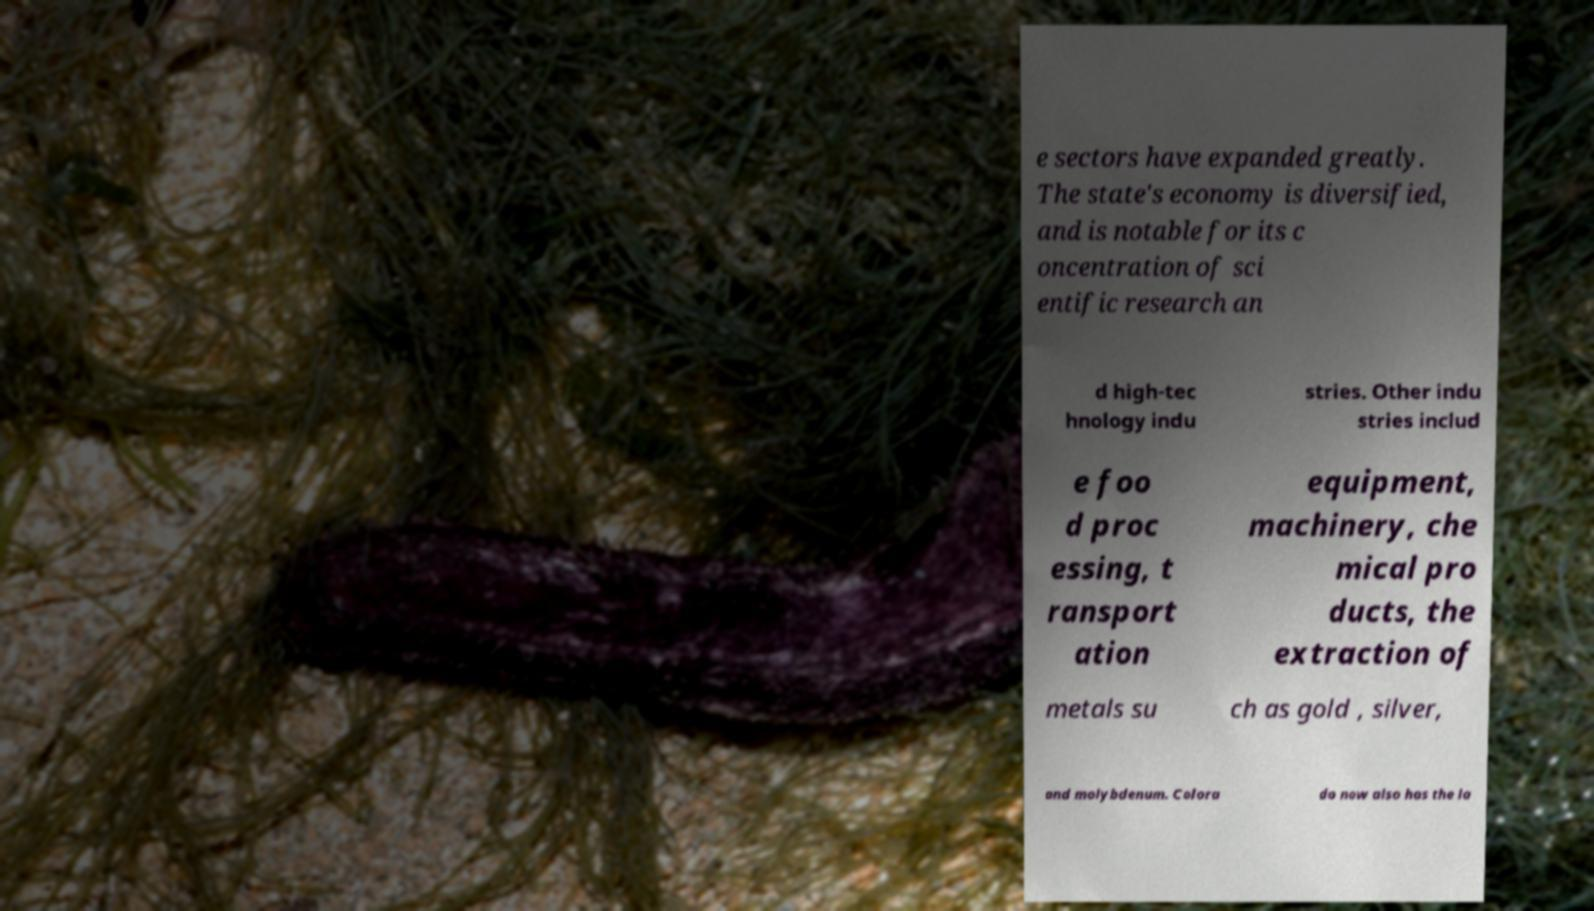Could you assist in decoding the text presented in this image and type it out clearly? e sectors have expanded greatly. The state's economy is diversified, and is notable for its c oncentration of sci entific research an d high-tec hnology indu stries. Other indu stries includ e foo d proc essing, t ransport ation equipment, machinery, che mical pro ducts, the extraction of metals su ch as gold , silver, and molybdenum. Colora do now also has the la 